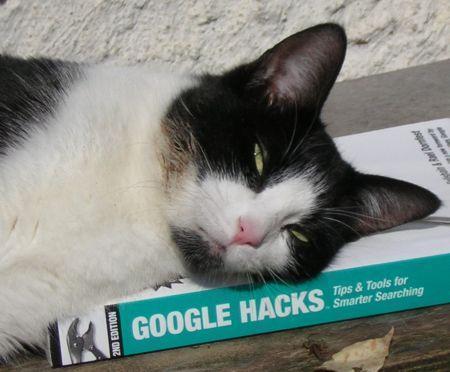How many trains are red?
Give a very brief answer. 0. 